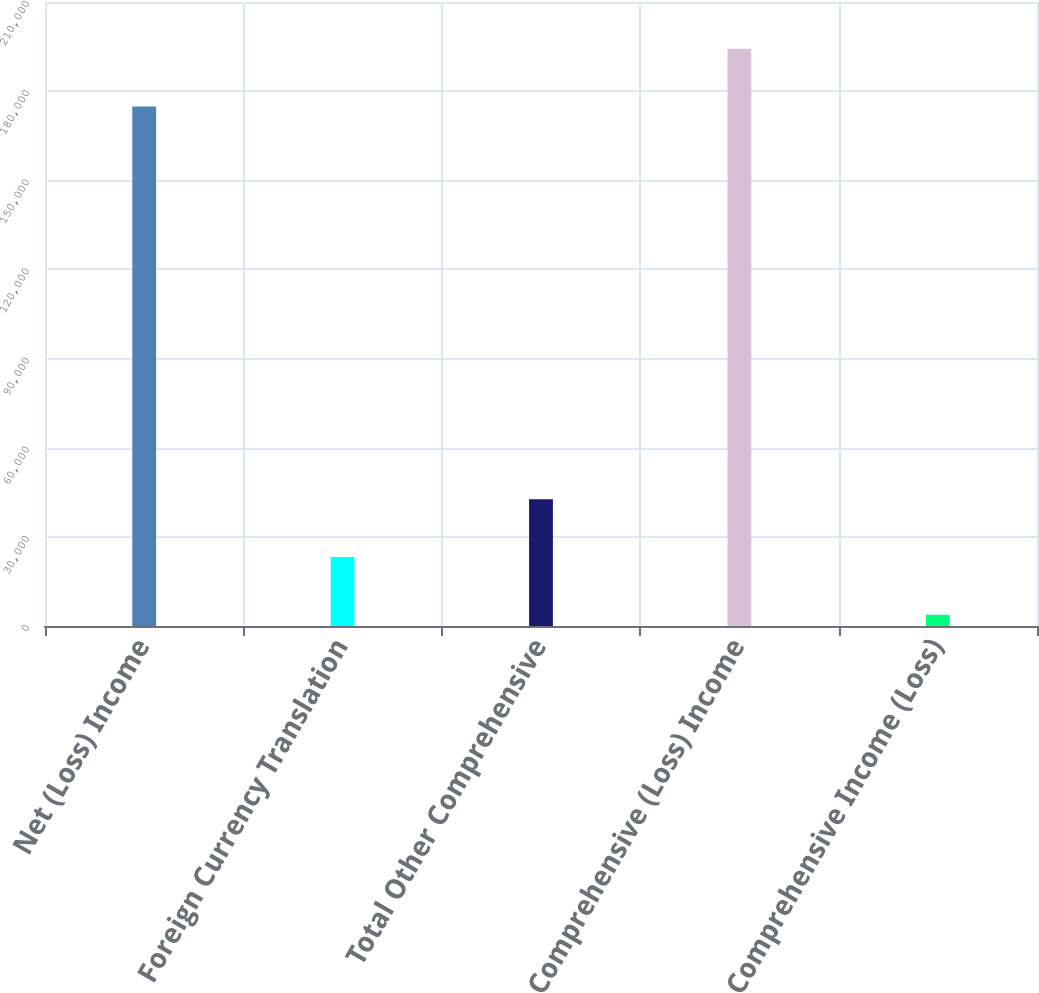<chart> <loc_0><loc_0><loc_500><loc_500><bar_chart><fcel>Net (Loss) Income<fcel>Foreign Currency Translation<fcel>Total Other Comprehensive<fcel>Comprehensive (Loss) Income<fcel>Comprehensive Income (Loss)<nl><fcel>174834<fcel>23217.5<fcel>42640<fcel>194256<fcel>3795<nl></chart> 